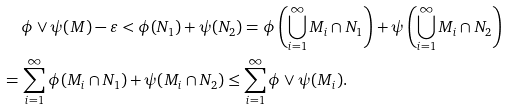<formula> <loc_0><loc_0><loc_500><loc_500>& \phi \vee \psi ( M ) - \varepsilon < \phi ( N _ { 1 } ) + \psi ( N _ { 2 } ) = \phi \left ( \bigcup _ { i = 1 } ^ { \infty } M _ { i } \cap N _ { 1 } \right ) + \psi \left ( \bigcup _ { i = 1 } ^ { \infty } M _ { i } \cap N _ { 2 } \right ) \\ = \, & \sum _ { i = 1 } ^ { \infty } \phi ( M _ { i } \cap N _ { 1 } ) + \psi ( M _ { i } \cap N _ { 2 } ) \leq \sum _ { i = 1 } ^ { \infty } \phi \vee \psi ( M _ { i } ) \text {.}</formula> 